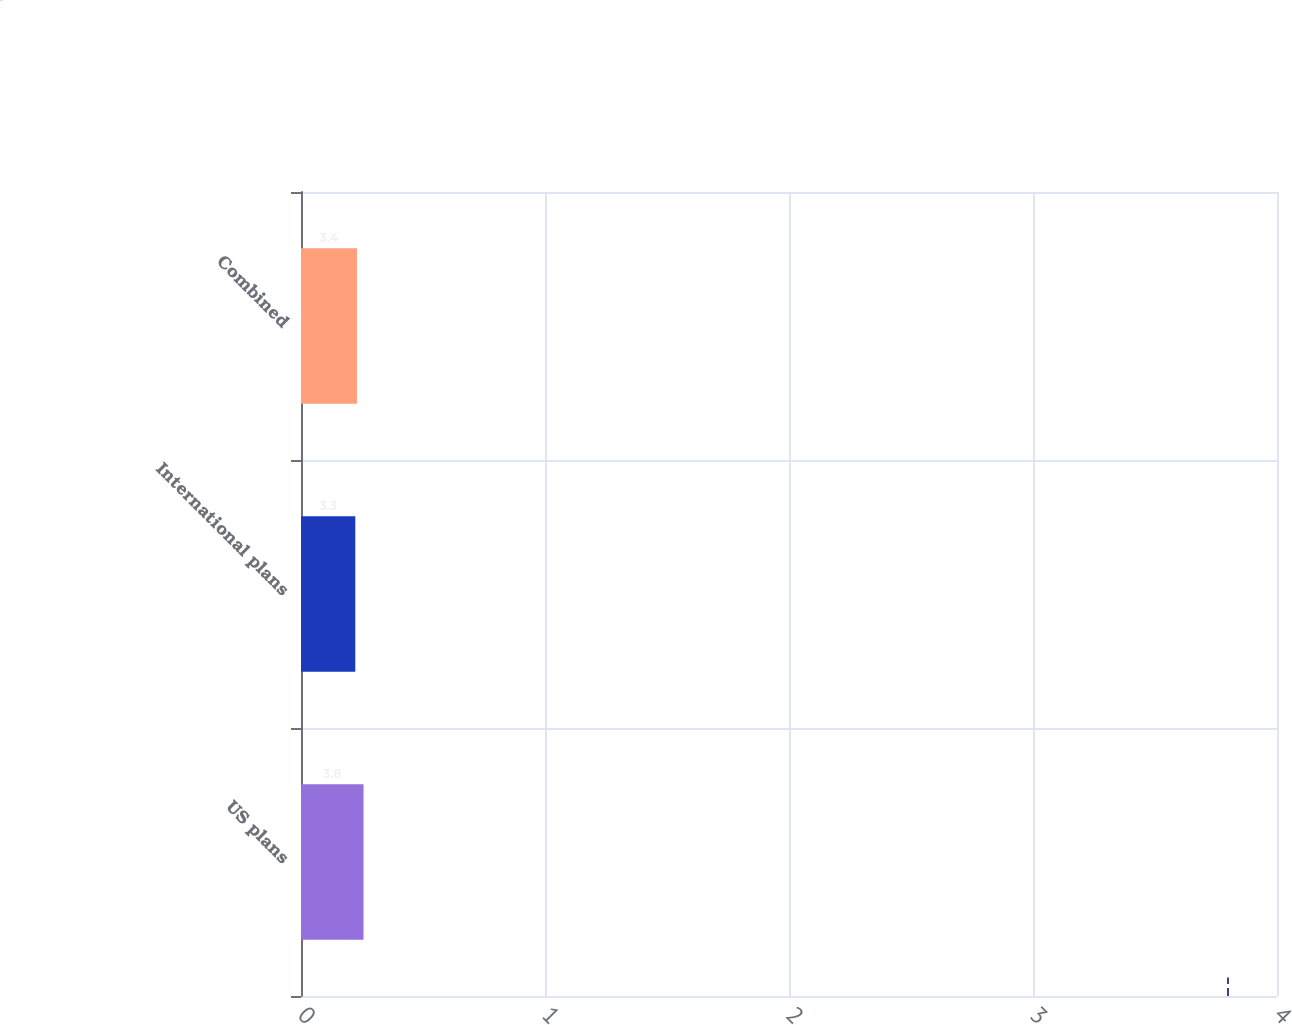<chart> <loc_0><loc_0><loc_500><loc_500><bar_chart><fcel>US plans<fcel>International plans<fcel>Combined<nl><fcel>3.8<fcel>3.3<fcel>3.4<nl></chart> 